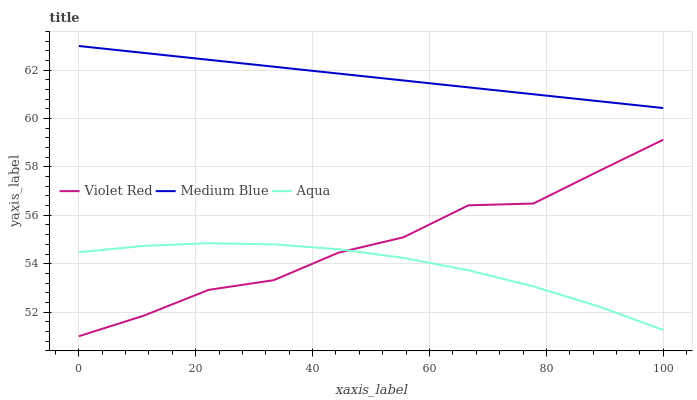Does Aqua have the minimum area under the curve?
Answer yes or no. Yes. Does Medium Blue have the maximum area under the curve?
Answer yes or no. Yes. Does Violet Red have the minimum area under the curve?
Answer yes or no. No. Does Violet Red have the maximum area under the curve?
Answer yes or no. No. Is Medium Blue the smoothest?
Answer yes or no. Yes. Is Violet Red the roughest?
Answer yes or no. Yes. Is Violet Red the smoothest?
Answer yes or no. No. Is Medium Blue the roughest?
Answer yes or no. No. Does Medium Blue have the lowest value?
Answer yes or no. No. Does Violet Red have the highest value?
Answer yes or no. No. Is Violet Red less than Medium Blue?
Answer yes or no. Yes. Is Medium Blue greater than Aqua?
Answer yes or no. Yes. Does Violet Red intersect Medium Blue?
Answer yes or no. No. 